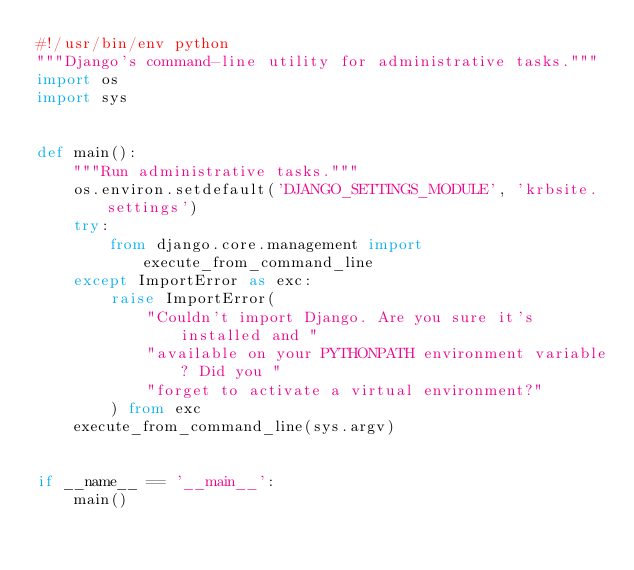<code> <loc_0><loc_0><loc_500><loc_500><_Python_>#!/usr/bin/env python
"""Django's command-line utility for administrative tasks."""
import os
import sys


def main():
    """Run administrative tasks."""
    os.environ.setdefault('DJANGO_SETTINGS_MODULE', 'krbsite.settings')
    try:
        from django.core.management import execute_from_command_line
    except ImportError as exc:
        raise ImportError(
            "Couldn't import Django. Are you sure it's installed and "
            "available on your PYTHONPATH environment variable? Did you "
            "forget to activate a virtual environment?"
        ) from exc
    execute_from_command_line(sys.argv)


if __name__ == '__main__':
    main()
</code> 